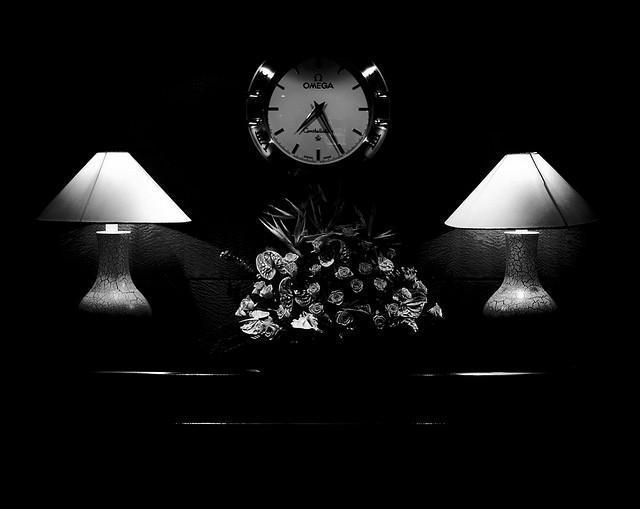How many lamps are shown?
Give a very brief answer. 2. How many vases are there?
Give a very brief answer. 1. 